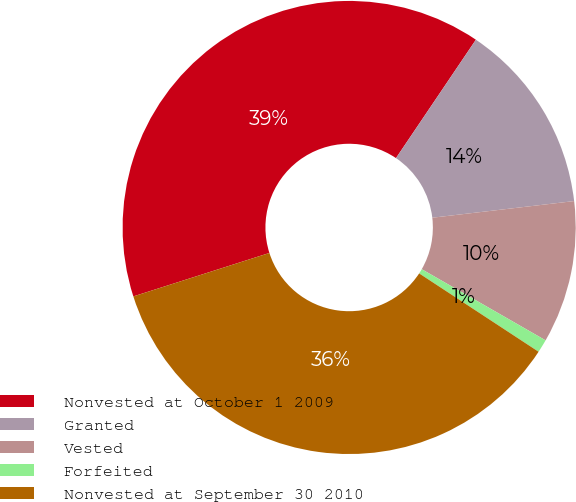Convert chart to OTSL. <chart><loc_0><loc_0><loc_500><loc_500><pie_chart><fcel>Nonvested at October 1 2009<fcel>Granted<fcel>Vested<fcel>Forfeited<fcel>Nonvested at September 30 2010<nl><fcel>39.37%<fcel>13.69%<fcel>10.16%<fcel>0.94%<fcel>35.84%<nl></chart> 